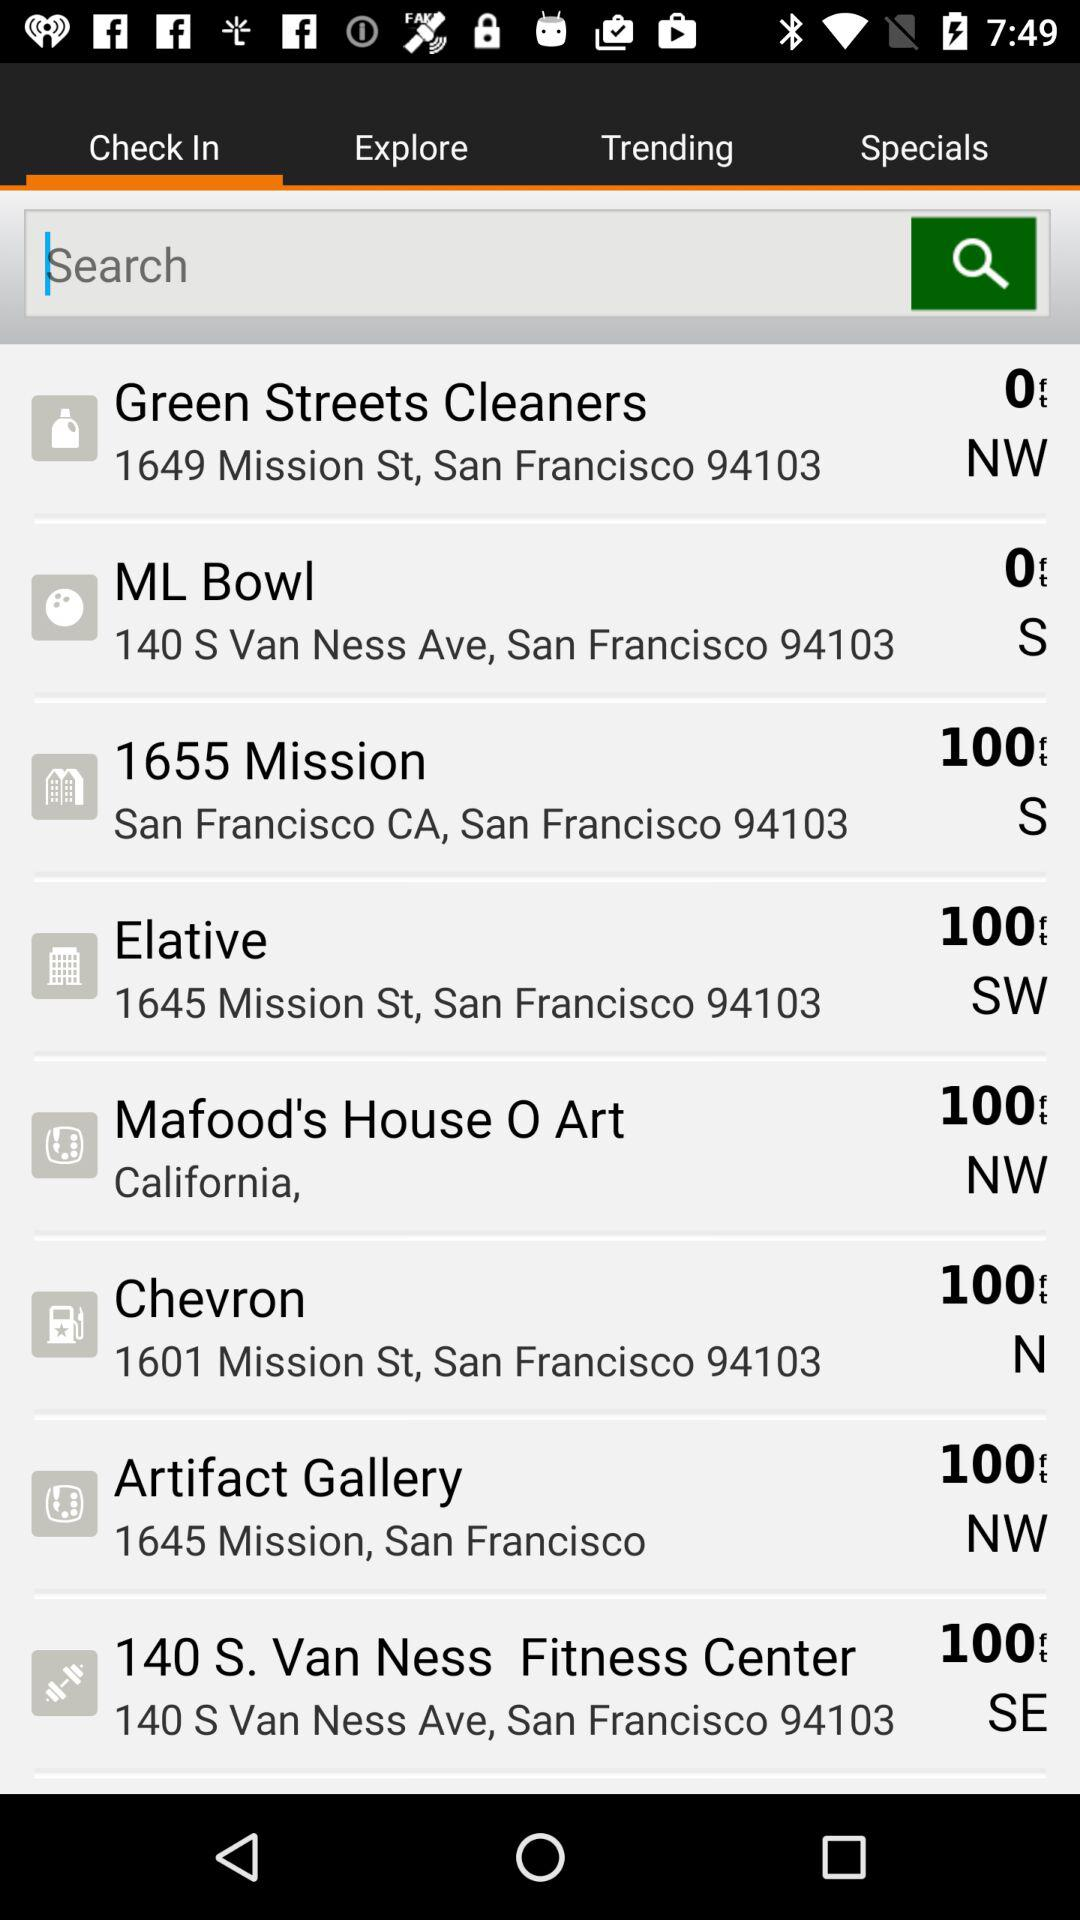What is the address of the Green Streets Cleaners? The address is 1649 Mission St, San Francisco 94103. 